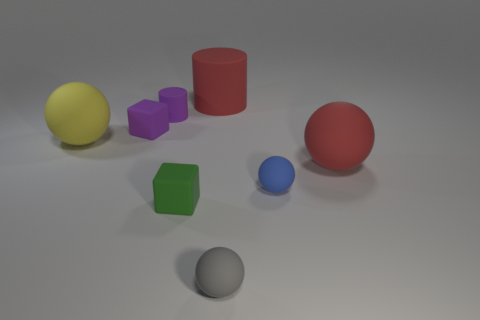What size is the yellow ball?
Provide a succinct answer. Large. What shape is the red rubber thing in front of the matte sphere that is on the left side of the small gray thing?
Keep it short and to the point. Sphere. How many other things are made of the same material as the tiny purple cube?
Provide a short and direct response. 7. Does the blue sphere have the same material as the green thing that is right of the small cylinder?
Give a very brief answer. Yes. How many objects are either large red things right of the small gray rubber object or red things in front of the tiny matte cylinder?
Offer a very short reply. 1. Are there more small rubber blocks behind the green object than big red matte things that are to the left of the big yellow matte ball?
Make the answer very short. Yes. How many balls are either blue rubber objects or gray objects?
Offer a very short reply. 2. What number of things are tiny rubber things that are behind the gray sphere or cylinders?
Provide a succinct answer. 5. What is the shape of the red thing that is behind the tiny object behind the small matte block behind the large yellow matte ball?
Give a very brief answer. Cylinder. How many large yellow things are the same shape as the gray thing?
Make the answer very short. 1. 